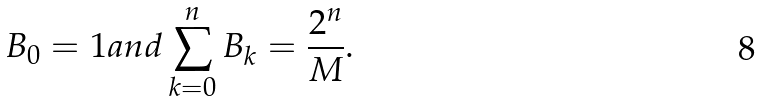Convert formula to latex. <formula><loc_0><loc_0><loc_500><loc_500>B _ { 0 } = 1 a n d \sum _ { k = 0 } ^ { n } B _ { k } = \frac { 2 ^ { n } } { M } .</formula> 